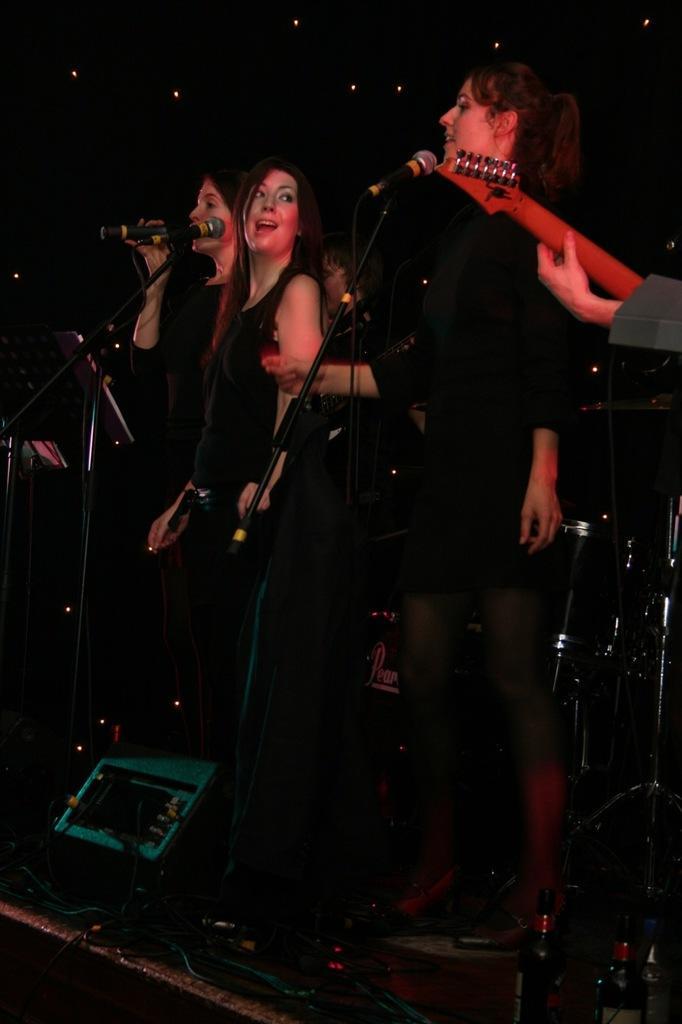Please provide a concise description of this image. In this picture we can see some persons are standing in front of mike. And these are the bottles. 